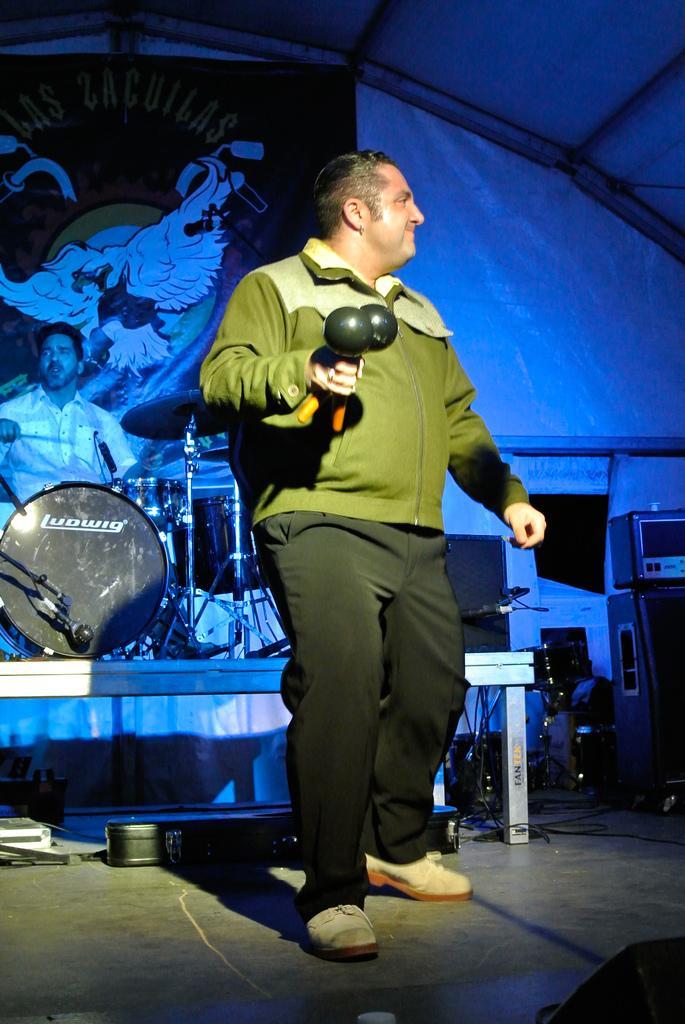How would you summarize this image in a sentence or two? In this picture we can see a person standing on the stage, he is holding some objects and in the background we can see a person, musical instruments, banner, sheet and some objects. 